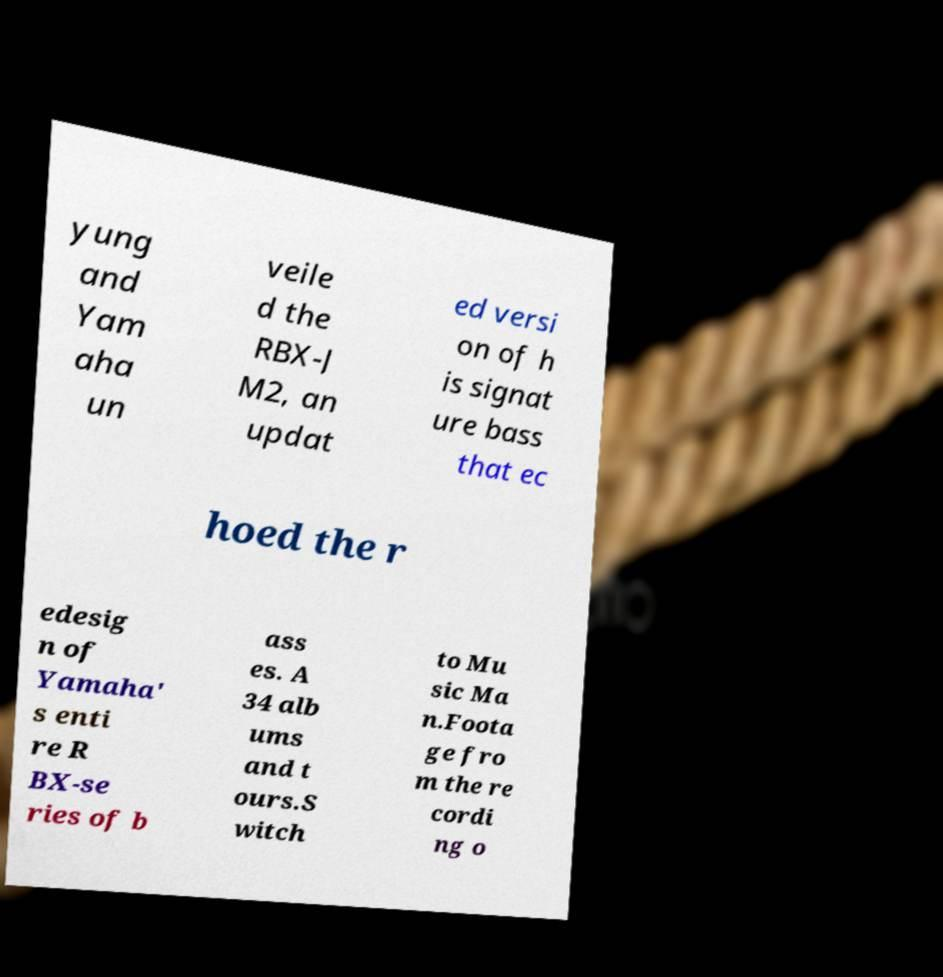Please read and relay the text visible in this image. What does it say? yung and Yam aha un veile d the RBX-J M2, an updat ed versi on of h is signat ure bass that ec hoed the r edesig n of Yamaha' s enti re R BX-se ries of b ass es. A 34 alb ums and t ours.S witch to Mu sic Ma n.Foota ge fro m the re cordi ng o 